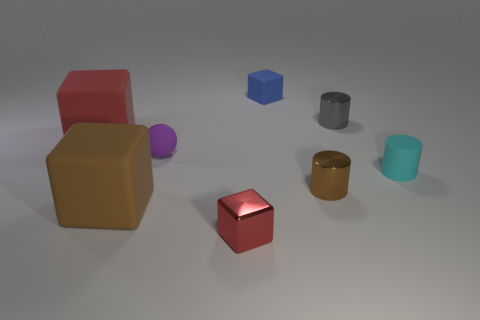Subtract all cyan cylinders. How many cylinders are left? 2 Subtract all red cubes. How many cubes are left? 2 Add 1 red rubber objects. How many objects exist? 9 Add 4 small brown rubber cylinders. How many small brown rubber cylinders exist? 4 Subtract 1 purple balls. How many objects are left? 7 Subtract all spheres. How many objects are left? 7 Subtract 1 cubes. How many cubes are left? 3 Subtract all brown cubes. Subtract all yellow balls. How many cubes are left? 3 Subtract all gray spheres. How many cyan cylinders are left? 1 Subtract all metal cylinders. Subtract all green blocks. How many objects are left? 6 